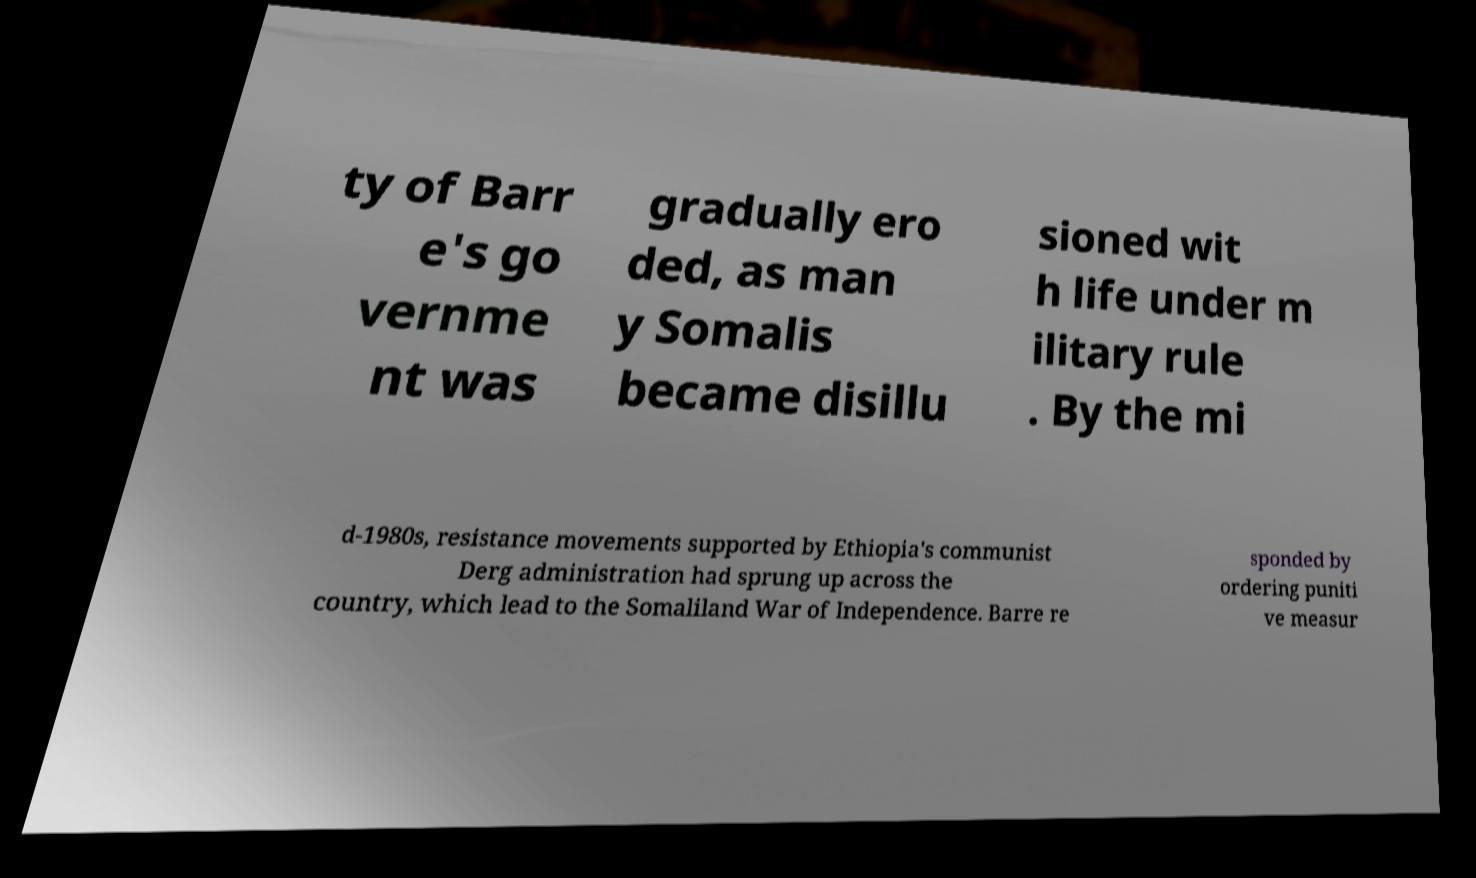Can you read and provide the text displayed in the image?This photo seems to have some interesting text. Can you extract and type it out for me? ty of Barr e's go vernme nt was gradually ero ded, as man y Somalis became disillu sioned wit h life under m ilitary rule . By the mi d-1980s, resistance movements supported by Ethiopia's communist Derg administration had sprung up across the country, which lead to the Somaliland War of Independence. Barre re sponded by ordering puniti ve measur 